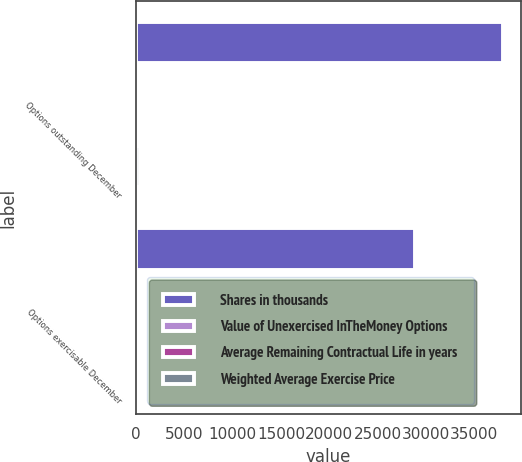Convert chart to OTSL. <chart><loc_0><loc_0><loc_500><loc_500><stacked_bar_chart><ecel><fcel>Options outstanding December<fcel>Options exercisable December<nl><fcel>Shares in thousands<fcel>37952<fcel>28905<nl><fcel>Value of Unexercised InTheMoney Options<fcel>54<fcel>53<nl><fcel>Average Remaining Contractual Life in years<fcel>3<fcel>3<nl><fcel>Weighted Average Exercise Price<fcel>430<fcel>358<nl></chart> 